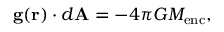<formula> <loc_0><loc_0><loc_500><loc_500>g ( r ) \cdot d A = - 4 \pi G M _ { e n c } ,</formula> 